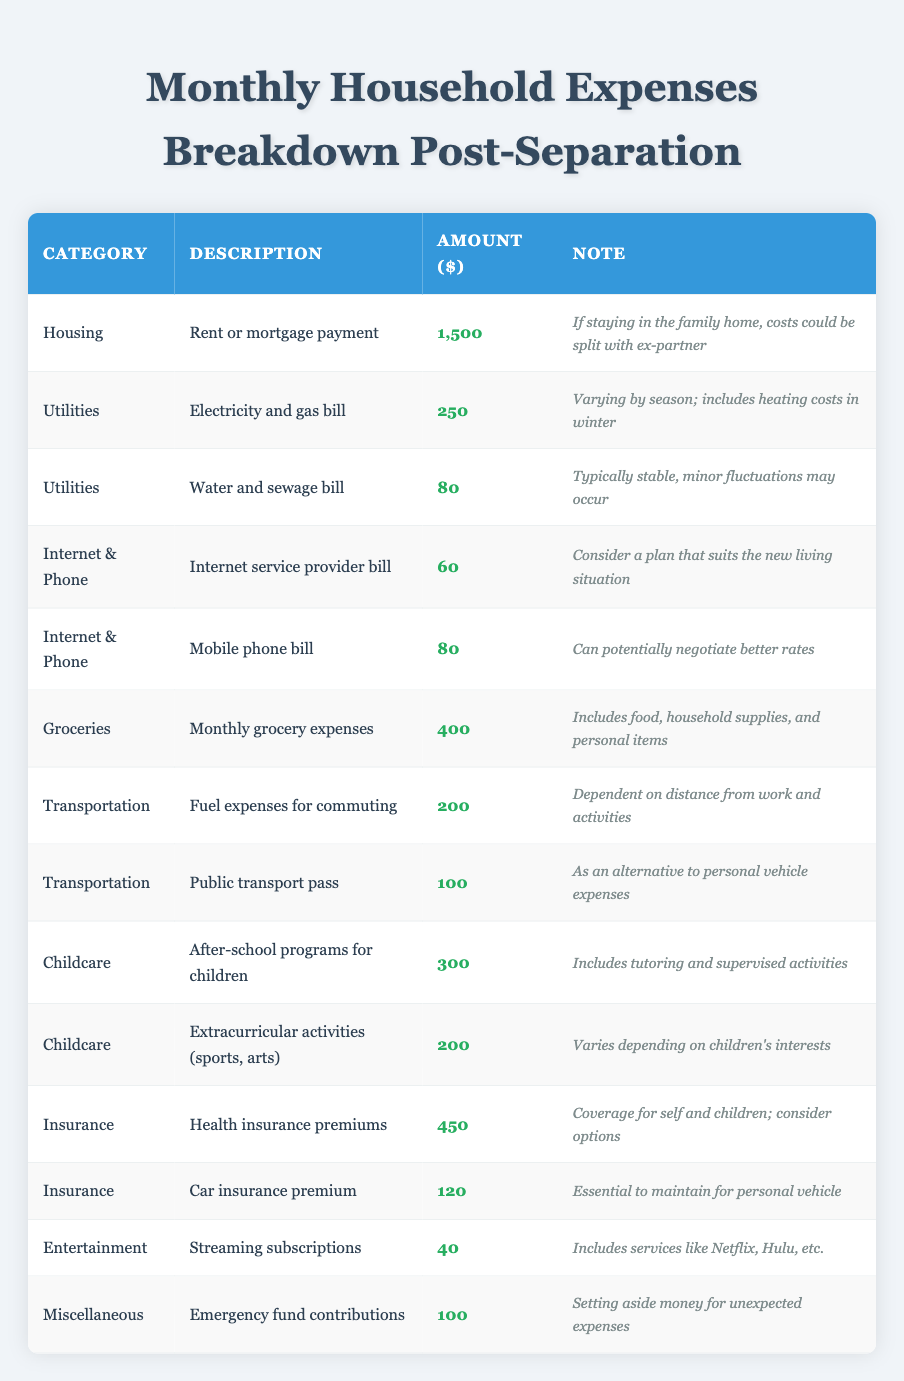What is the total monthly average expense for utilities? There are two utility expenses listed: Electricity and gas bill for $250 and Water and sewage bill for $80. The total for utilities is 250 + 80 = 330. To find the average for these two categories, divide the total by 2, which gives 330 / 2 = 165.
Answer: 165 How much is spent on groceries monthly? The grocery expense is listed as $400 in the table.
Answer: 400 What is the total cost of childcare? There are two childcare expenses listed: After-school programs for children at $300 and Extracurricular activities at $200. To find the total, add these two amounts together: 300 + 200 = 500.
Answer: 500 Are health insurance premiums higher than car insurance premiums? The health insurance premium is $450, while the car insurance premium is $120. As 450 is greater than 120, the statement is true.
Answer: Yes What percentage of the total monthly expenses is allocated to housing? Housing costs $1500, and the total expenses can be calculated as: 1500 (housing) + 330 (utilities) + 60 (internet) + 80 (mobile) + 400 (groceries) + 200 (fuel) + 100 (transport pass) + 300 (after-school) + 200 (extracurricular) + 450 (health insurance) + 120 (car insurance) + 40 (entertainment) + 100 (emergency fund) = 3,060. To find the percentage, calculate (1500 / 3060) * 100 = 49.02%.
Answer: 49.02% What is the total monthly expense for internet and phone? The total for internet and phone includes Internet service for $60 and Mobile phone for $80. Summing these gives 60 + 80 = 140.
Answer: 140 What are the total utilities expenses for the month? The utilities expenses include the Electricity and gas bill for $250 and the Water and sewage bill for $80. By adding them together, we find that the total is 250 + 80 = 330.
Answer: 330 Is the total for transportation greater than the total for groceries? The transportation costs include Fuel expenses for $200 and Public transport pass for $100, totaling 200 + 100 = 300. The grocery expense is $400. Since 300 is less than 400, the statement is false.
Answer: No What is the total expenditure on entertainment and miscellaneous combined? The total for entertainment is $40 and for miscellaneous is $100. Adding these amounts gives 40 + 100 = 140.
Answer: 140 How much money is set aside for an emergency fund? The emergency fund contribution is listed as $100 in the table.
Answer: 100 Which category has the highest monthly expense? Upon reviewing the categories, Housing has the highest expense at $1500, more than any other listed category.
Answer: Housing 